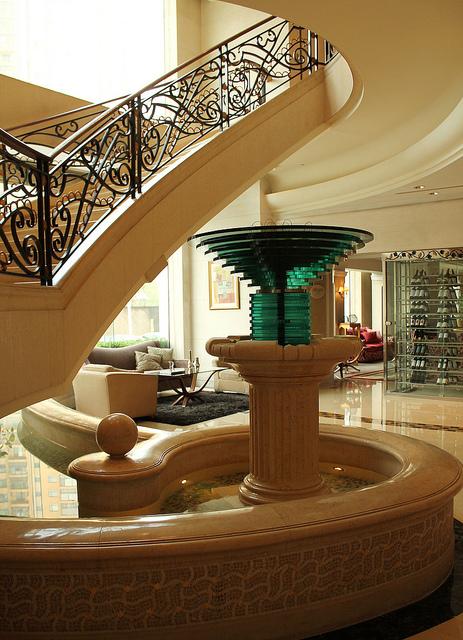Is the green part of the fountain opaque or translucent?
Answer briefly. Translucent. What is in the glass case?
Short answer required. Wine. Is the fountain on?
Write a very short answer. No. 